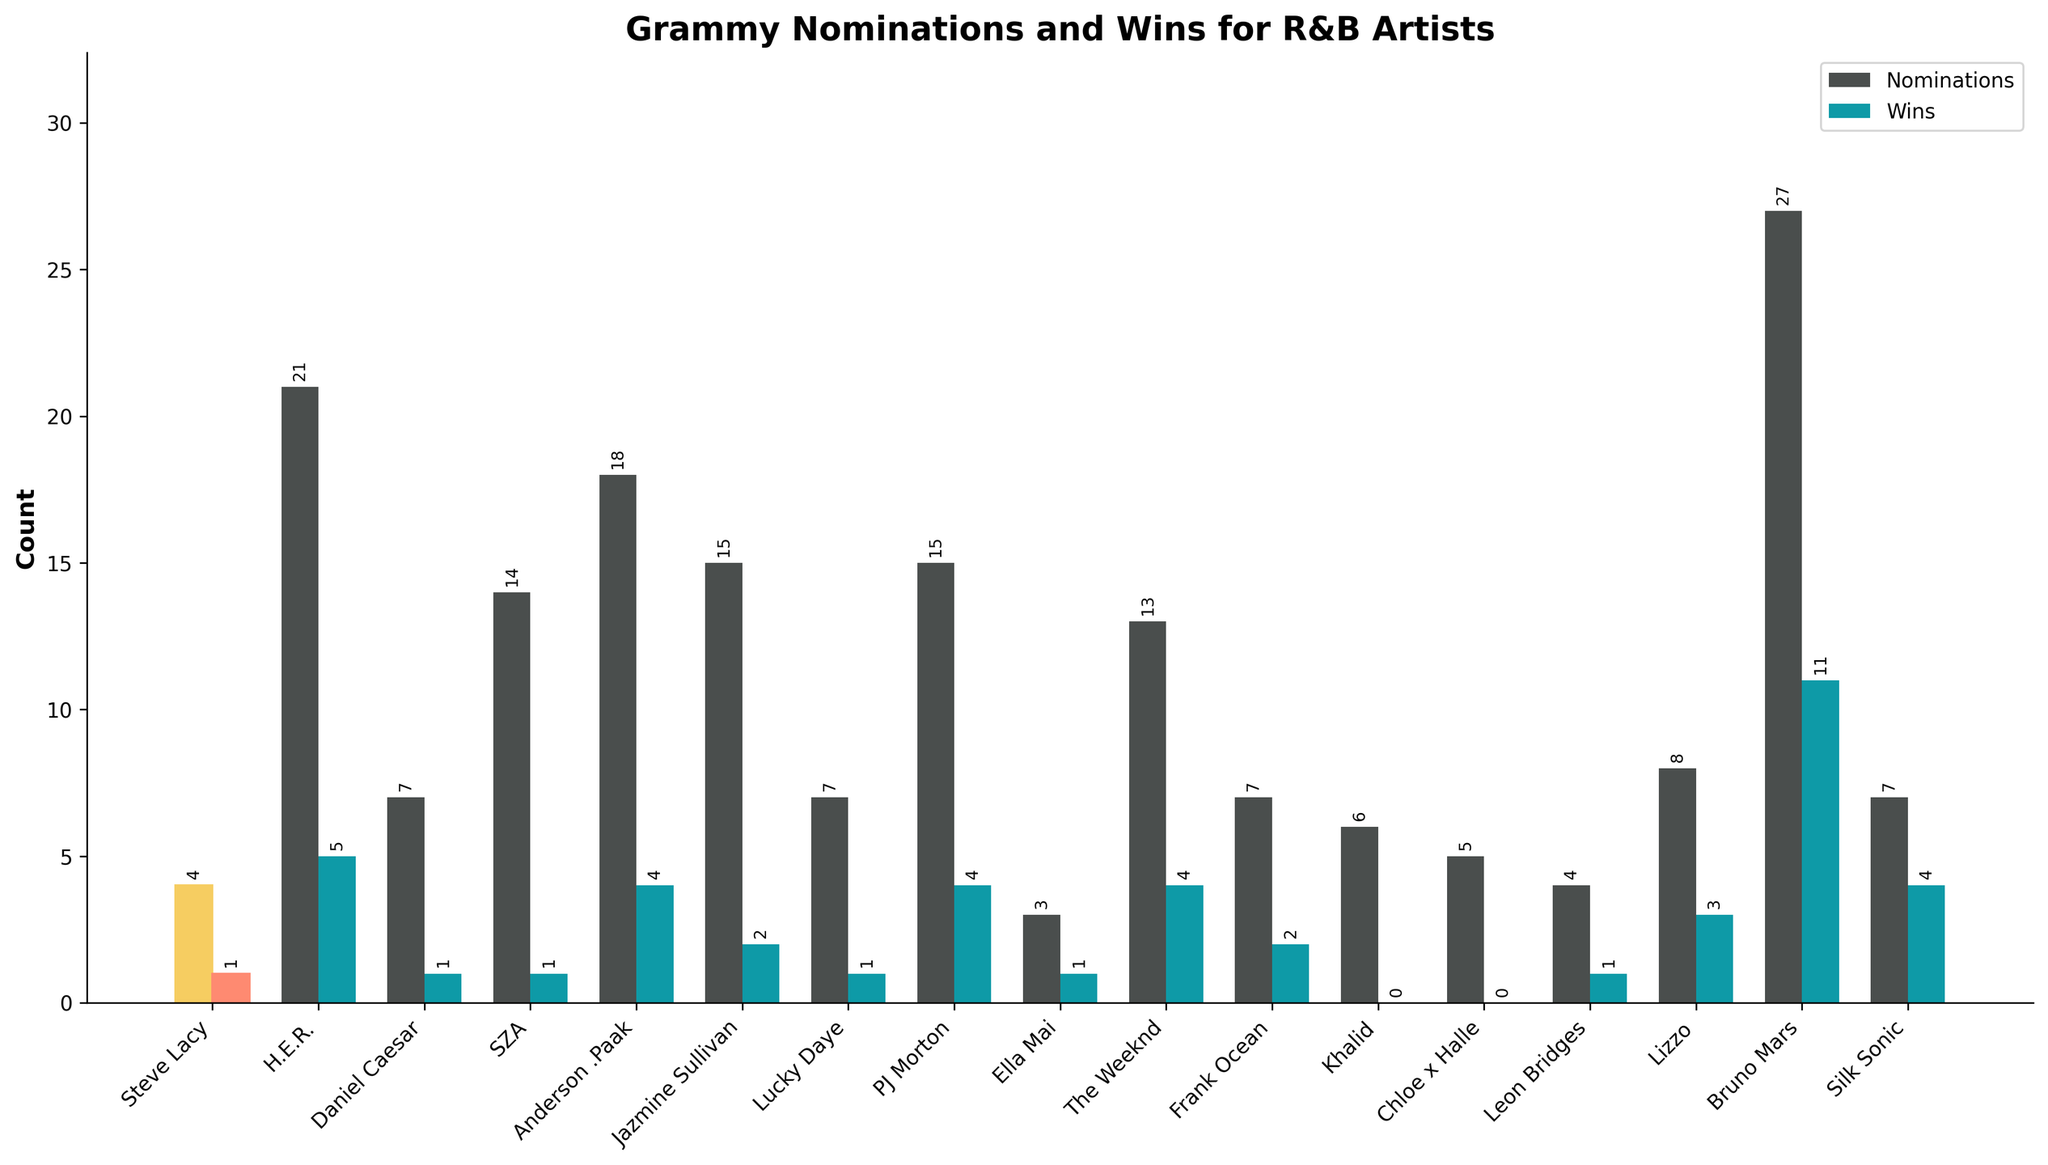what's the difference between Grammy wins of Steve Lacy and H.E.R.? Steve Lacy has 1 Grammy win, and H.E.R. has 5 Grammy wins. So, the difference is 5 - 1 = 4
Answer: 4 which artist has the highest number of Grammy nominations? By looking at the heights of the bars representing nominations, Bruno Mars has the highest number with 27 nominations
Answer: Bruno Mars how many total Grammy wins do Anderson .Paak, PJ Morton, and Silk Sonic have combined? Anderson .Paak has 4 Grammy wins, PJ Morton has 4, and Silk Sonic also has 4. Together, they have 4 + 4 + 4 = 12 wins
Answer: 12 who has more Grammy wins, The Weeknd or Lizzo? The Weeknd has 4 Grammy wins, while Lizzo has 3. Therefore, The Weeknd has more Grammy wins
Answer: The Weeknd what's the sum of Grammy nominations for Daniel Caesar and Lucky Daye? Daniel Caesar has 7 nominations, and Lucky Daye has 7. The sum is 7 + 7 = 14
Answer: 14 is the height of the Grammy wins bar for Khalid higher, equal to, or lower than that for SZA? The Grammy wins bar for Khalid is lower than that for SZA. Khalid has 0 wins while SZA has 1
Answer: lower which artist has more Grammy nominations, Steve Lacy or Leon Bridges? Steve Lacy has 4 Grammy nominations while Leon Bridges has the same. Their numbers are equal
Answer: equal how many artists have exactly 1 Grammy win? By looking at the figure, the artists with exactly 1 Grammy win are Steve Lacy, Daniel Caesar, SZA, Lucky Daye, and Ella Mai. This totals to 5 artists
Answer: 5 what's the average number of Grammy nominations for The Weeknd, Frank Ocean, and Khalid? The Weeknd has 13 nominations, Frank Ocean has 7, and Khalid has 6. The total is 13 + 7 + 6 = 26, and the average is 26 / 3 ≈ 8.67
Answer: 8.67 